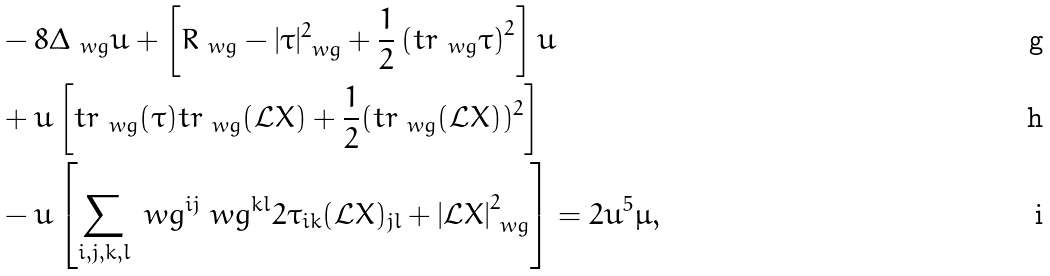Convert formula to latex. <formula><loc_0><loc_0><loc_500><loc_500>& - 8 \Delta _ { \ w g } u + \left [ R _ { \ w g } - | \tau | ^ { 2 } _ { \ w g } + \frac { 1 } { 2 } \left ( t r _ { \ w g } \tau \right ) ^ { 2 } \right ] u \\ & + u \left [ t r _ { \ w g } ( \tau ) t r _ { \ w g } ( \mathcal { L } X ) + \frac { 1 } { 2 } ( t r _ { \ w g } ( \mathcal { L } X ) ) ^ { 2 } \right ] \\ & - u \left [ \sum _ { i , j , k , l } \ w g ^ { i j } \ w g ^ { k l } 2 \tau _ { i k } ( \mathcal { L } X ) _ { j l } + \left | \mathcal { L } X \right | _ { \ w g } ^ { 2 } \right ] = 2 u ^ { 5 } \mu ,</formula> 